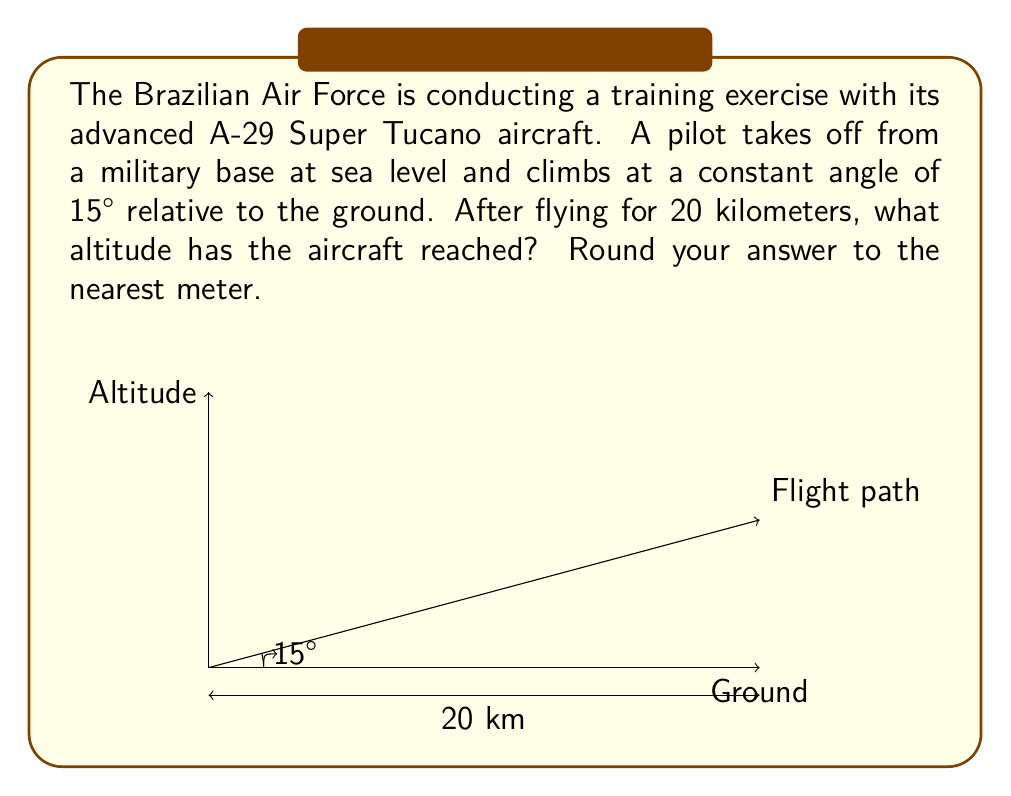Help me with this question. To solve this problem, we'll use trigonometric functions, specifically the sine function. Here's how we can approach it:

1) In a right triangle, sine of an angle is the ratio of the opposite side to the hypotenuse.

2) In this case:
   - The angle of elevation is 15°
   - The hypotenuse (flight path) is 20 km
   - We need to find the opposite side (altitude)

3) Let's set up our equation:

   $$\sin(15°) = \frac{\text{altitude}}{20 \text{ km}}$$

4) Solving for altitude:

   $$\text{altitude} = 20 \text{ km} \times \sin(15°)$$

5) Now, let's calculate:
   
   $$\begin{align}
   \text{altitude} &= 20 \times \sin(15°) \\
   &= 20 \times 0.2588... \\
   &= 5.176... \text{ km}
   \end{align}$$

6) Converting to meters:
   
   $$5.176... \text{ km} = 5176... \text{ m}$$

7) Rounding to the nearest meter:

   $$5176 \text{ m}$$

This calculation demonstrates how trigonometric functions can be used to determine the trajectory of military aircraft, which is crucial for Brazilian Air Force operations and training exercises.
Answer: 5176 meters 